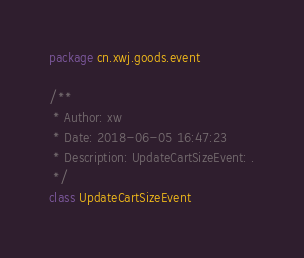<code> <loc_0><loc_0><loc_500><loc_500><_Kotlin_>package cn.xwj.goods.event

/**
 * Author: xw
 * Date: 2018-06-05 16:47:23
 * Description: UpdateCartSizeEvent: .
 */
class UpdateCartSizeEvent</code> 